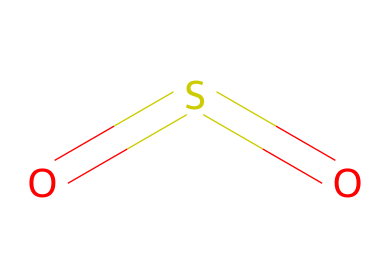What is the molecular formula of this compound? The compound shown in the SMILES representation is sulfur dioxide, which consists of one sulfur atom and two oxygen atoms. Therefore, the molecular formula is determined by counting these atoms.
Answer: SO2 How many double bonds are present in the structure? The SMILES representation O=S=O indicates that there are two double bonds between the sulfur atom and each of the two oxygen atoms. This can be identified by the '=' symbol, which denotes double bonds.
Answer: 2 What is the hybridization of the sulfur atom in this molecule? In sulfur dioxide, the sulfur atom is bonded to two oxygen atoms through double bonds. This leads to a trigonal planar geometry, which corresponds to sp2 hybridization as there are three electron regions around the sulfur atom.
Answer: sp2 Is sulfur dioxide a greenhouse gas? Sulfur dioxide (SO2) is recognized as a greenhouse gas due to its contribution to atmospheric warming and its role in the formation of acids. This is known based on its chemical properties and effects when released into the atmosphere.
Answer: Yes What is the primary role of sulfur dioxide in food preservation? Sulfur dioxide is primarily used as a preservative and antioxidant in the food industry to prevent spoilage and maintain color. Its antimicrobial properties help to inhibit the growth of bacteria and fungi in food products.
Answer: Preservative 